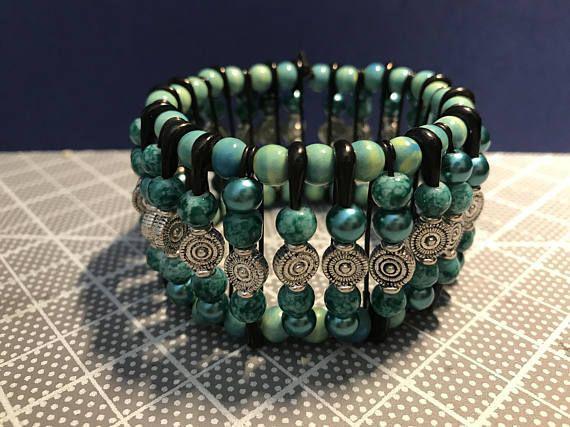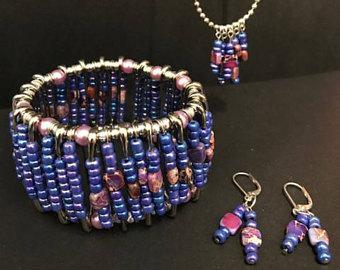The first image is the image on the left, the second image is the image on the right. Assess this claim about the two images: "A bracelet is lying on a surface in each of the images.". Correct or not? Answer yes or no. Yes. The first image is the image on the left, the second image is the image on the right. Evaluate the accuracy of this statement regarding the images: "One image shows a safety pin necklace on a black display, and the other image shows a bracelet made with silver safety pins.". Is it true? Answer yes or no. No. 